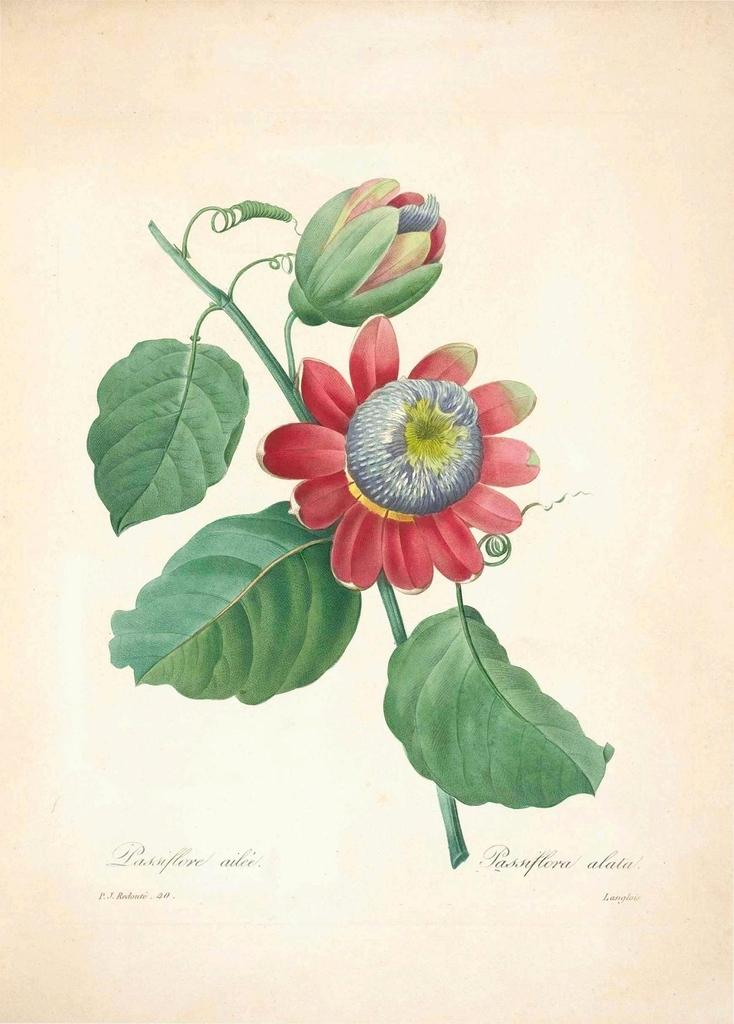What is depicted in the painting in the image? There is a painting of a plant in the image. What features can be observed on the plant in the painting? The plant has leaves, a flower, and a flower bud. What type of writing is present under the painting? There is cursive writing under the painting. What type of advertisement can be seen in the painting? There is no advertisement present in the painting; it is a depiction of a plant with leaves, a flower, and a flower bud. What kind of patch is visible on the plant in the painting? There is no patch visible on the plant in the painting; it is a representation of a plant with leaves, a flower, and a flower bud. 